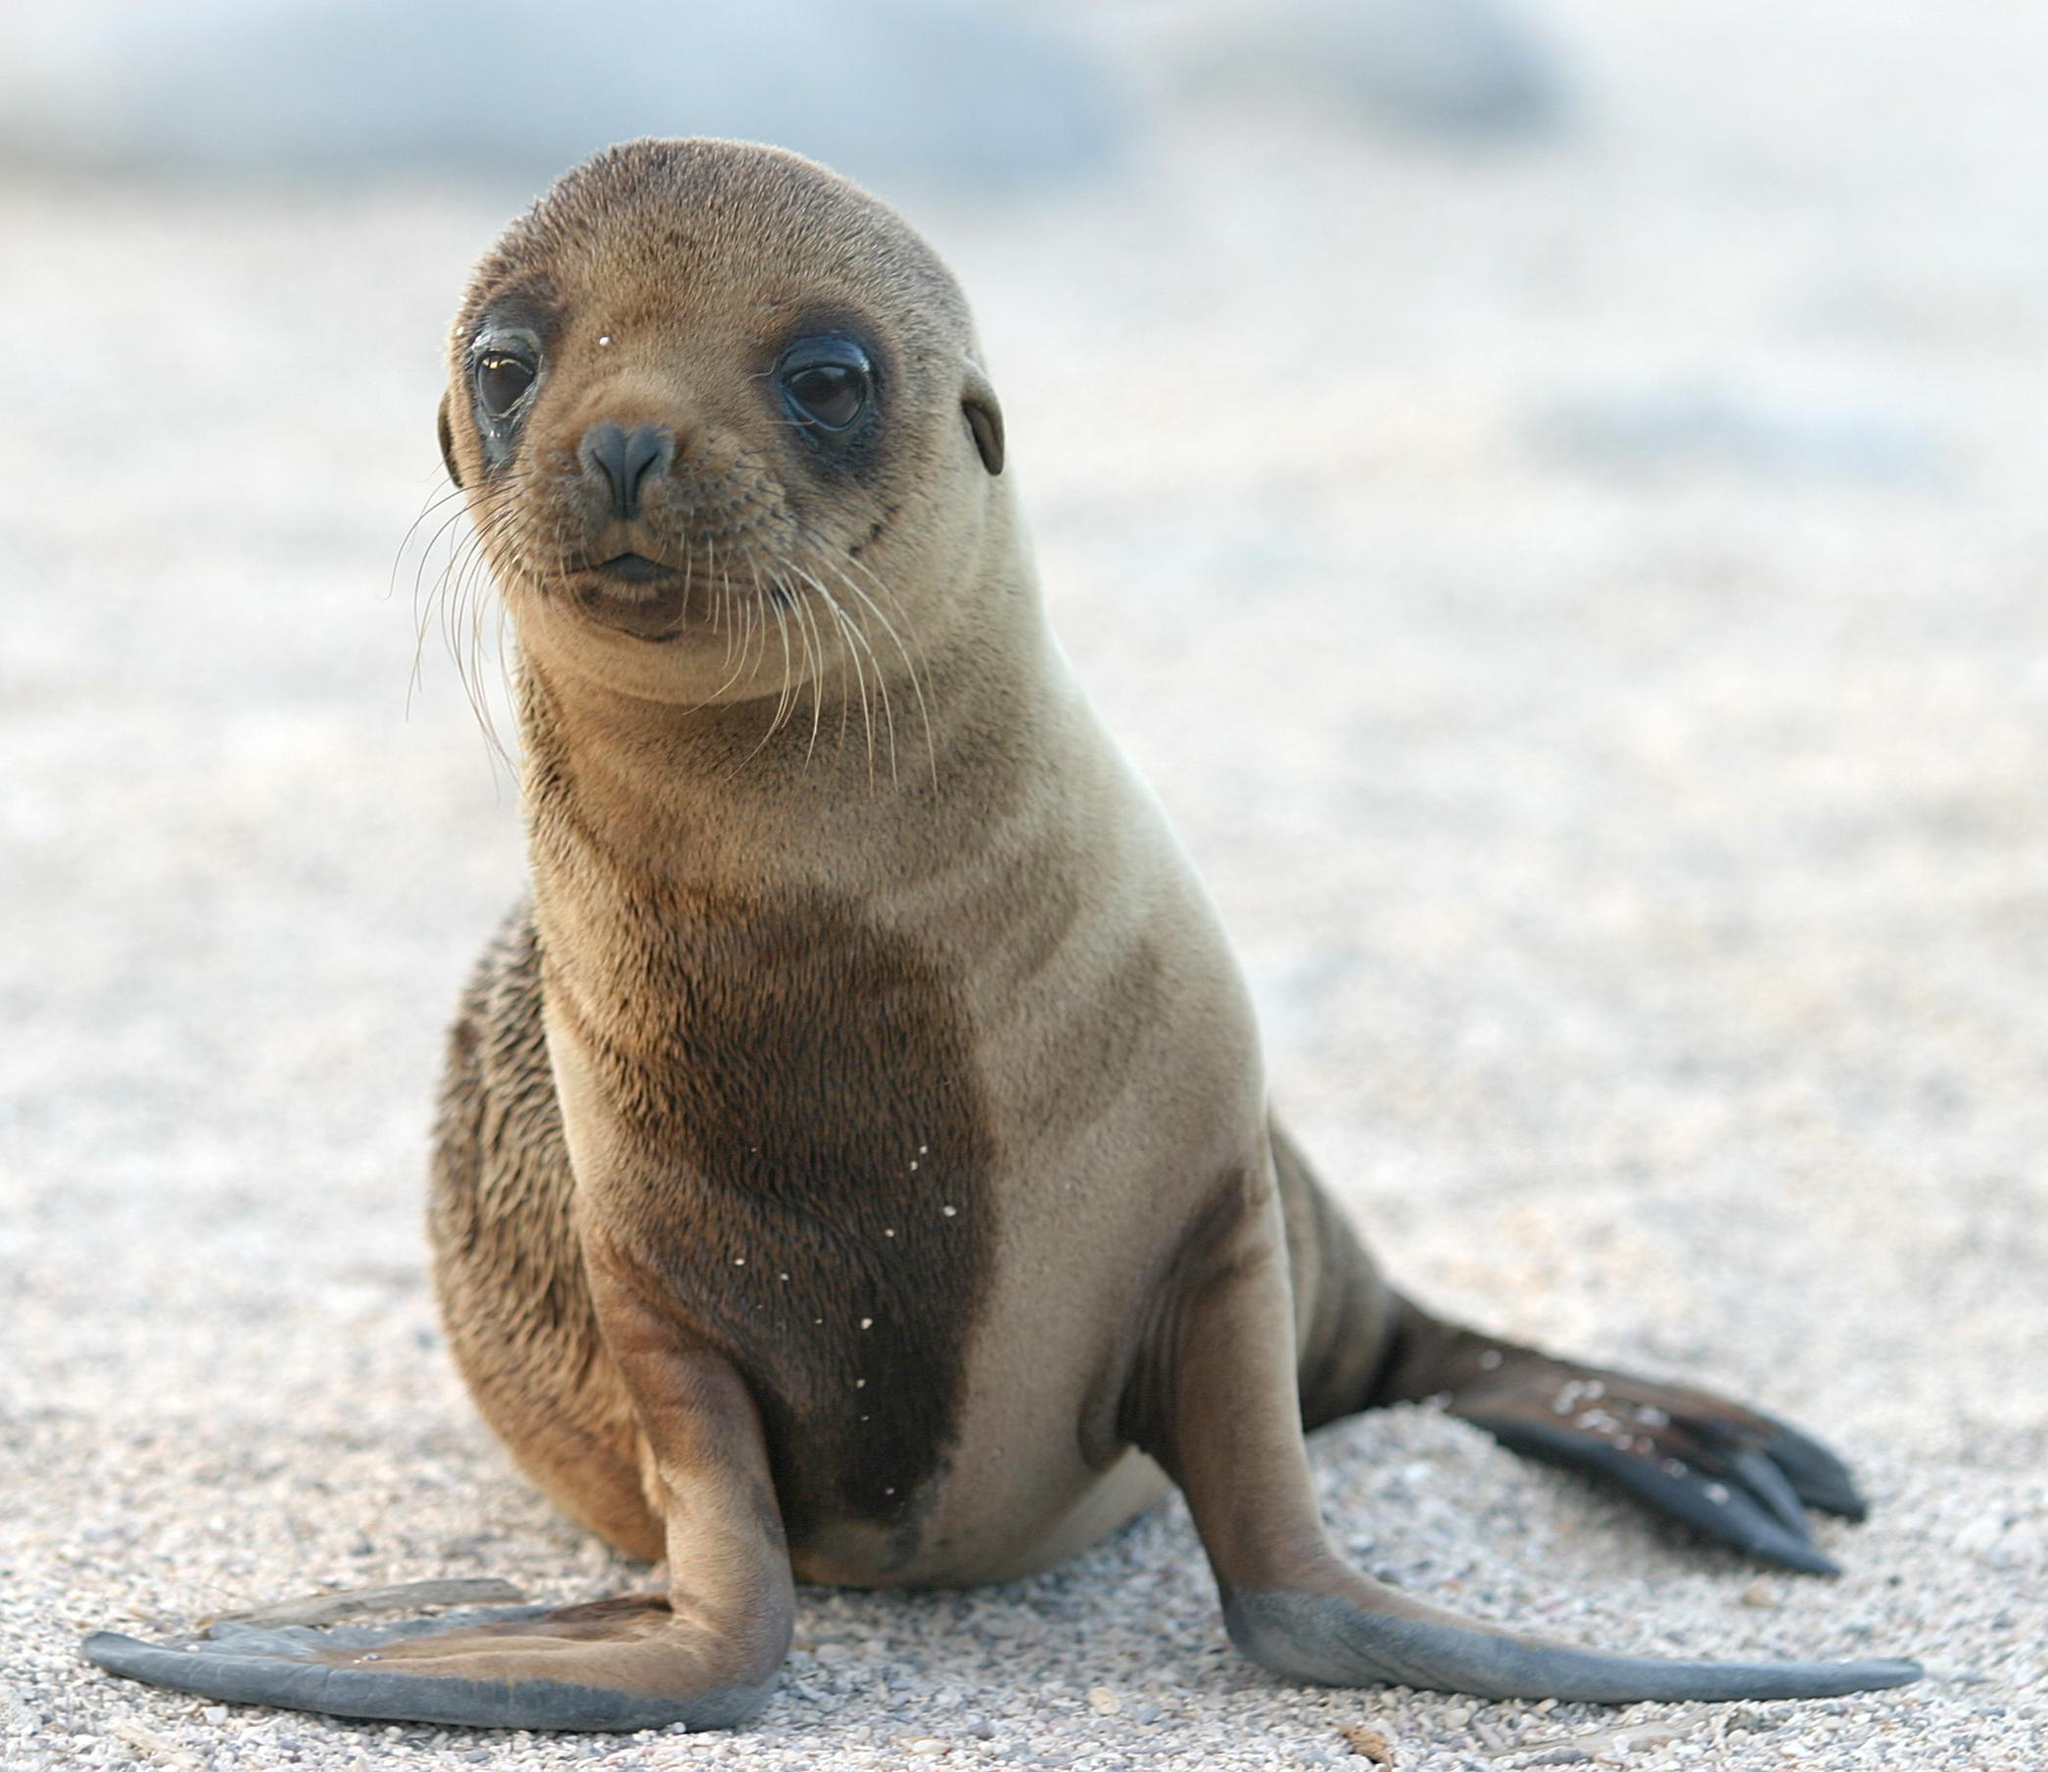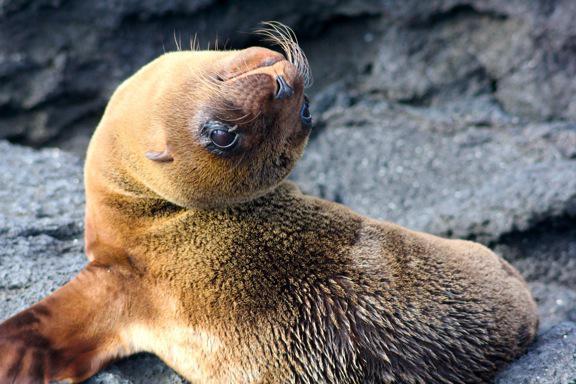The first image is the image on the left, the second image is the image on the right. For the images displayed, is the sentence "Two seals are on a sandy surface in the image on the left." factually correct? Answer yes or no. No. 